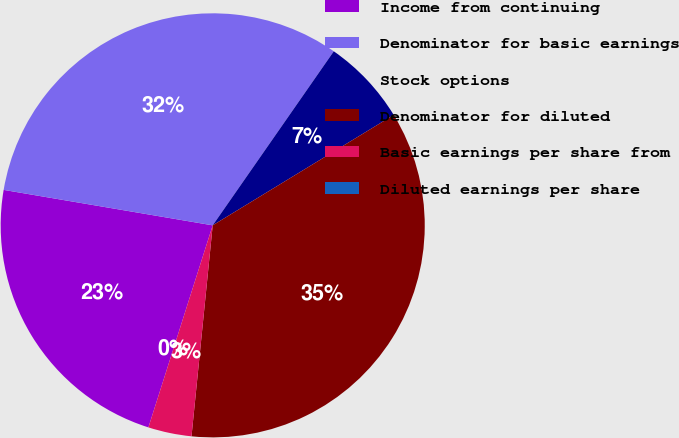<chart> <loc_0><loc_0><loc_500><loc_500><pie_chart><fcel>Income from continuing<fcel>Denominator for basic earnings<fcel>Stock options<fcel>Denominator for diluted<fcel>Basic earnings per share from<fcel>Diluted earnings per share<nl><fcel>22.77%<fcel>32.0%<fcel>6.61%<fcel>35.31%<fcel>3.31%<fcel>0.0%<nl></chart> 